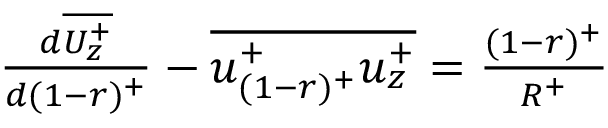<formula> <loc_0><loc_0><loc_500><loc_500>\begin{array} { r } { \frac { d \overline { { U _ { z } ^ { + } } } } { d ( 1 - r ) ^ { + } } - \overline { { u _ { ( 1 - r ) ^ { + } } ^ { + } u _ { z } ^ { + } } } = { \frac { ( 1 - r ) ^ { + } } { R ^ { + } } } } \end{array}</formula> 